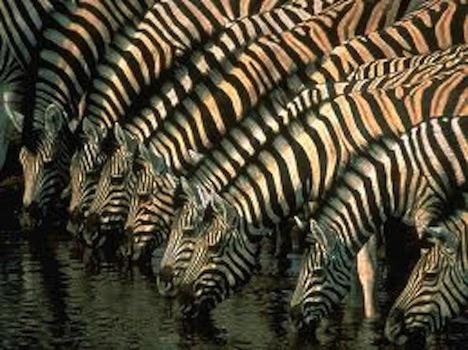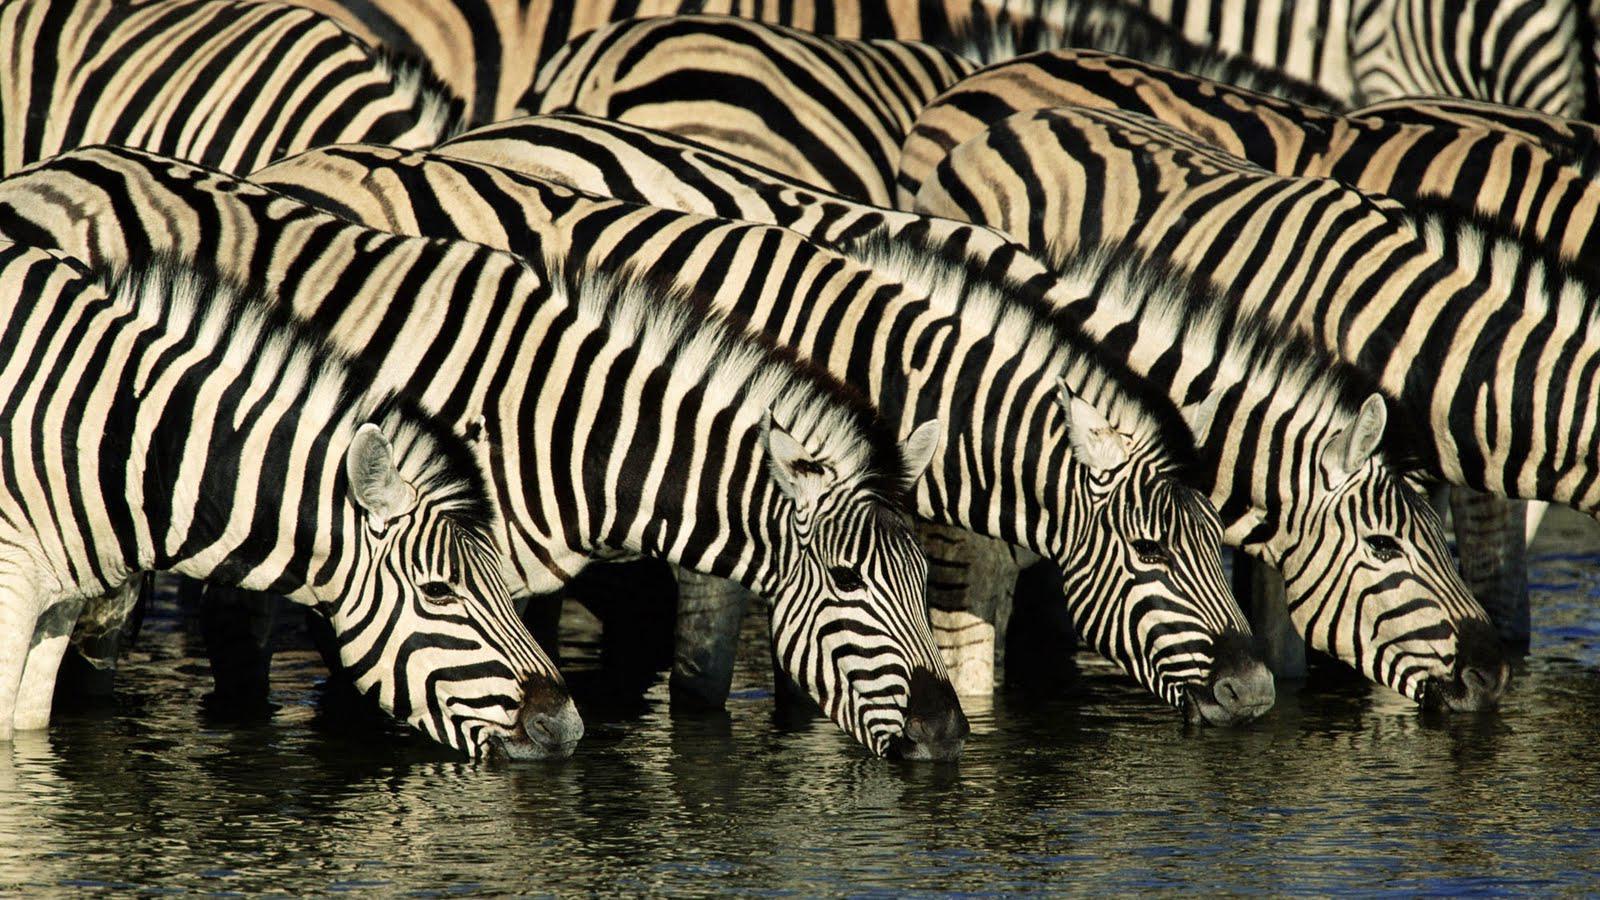The first image is the image on the left, the second image is the image on the right. Considering the images on both sides, is "At least five zebras are drinking water." valid? Answer yes or no. Yes. The first image is the image on the left, the second image is the image on the right. For the images shown, is this caption "In at least one image, zebras are drinking water." true? Answer yes or no. Yes. 